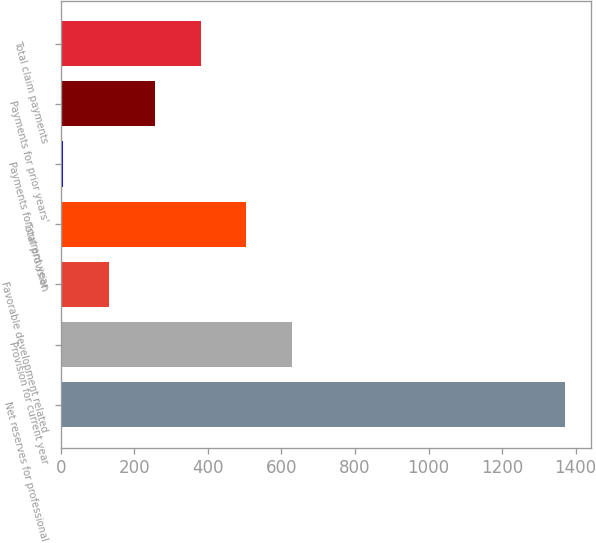Convert chart. <chart><loc_0><loc_0><loc_500><loc_500><bar_chart><fcel>Net reserves for professional<fcel>Provision for current year<fcel>Favorable development related<fcel>Total provision<fcel>Payments for current year<fcel>Payments for prior years'<fcel>Total claim payments<nl><fcel>1372.5<fcel>629.5<fcel>131.5<fcel>505<fcel>7<fcel>256<fcel>380.5<nl></chart> 